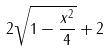<formula> <loc_0><loc_0><loc_500><loc_500>2 \sqrt { 1 - \frac { x ^ { 2 } } { 4 } } + 2</formula> 